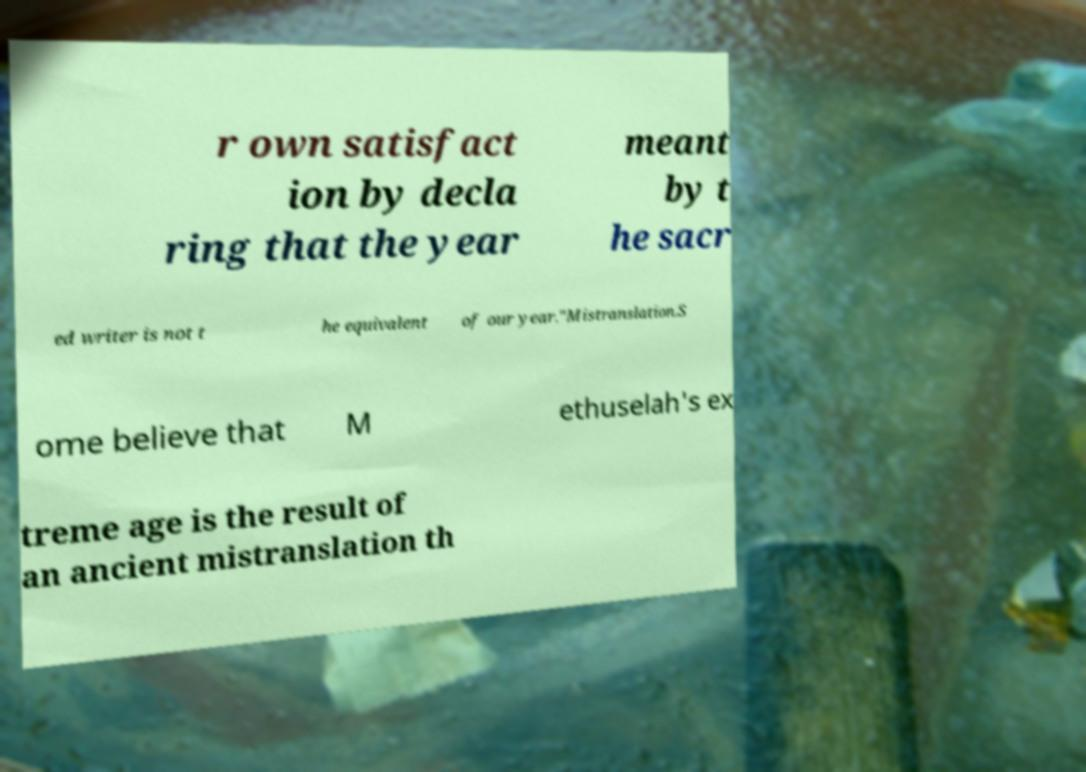Please identify and transcribe the text found in this image. r own satisfact ion by decla ring that the year meant by t he sacr ed writer is not t he equivalent of our year."Mistranslation.S ome believe that M ethuselah's ex treme age is the result of an ancient mistranslation th 